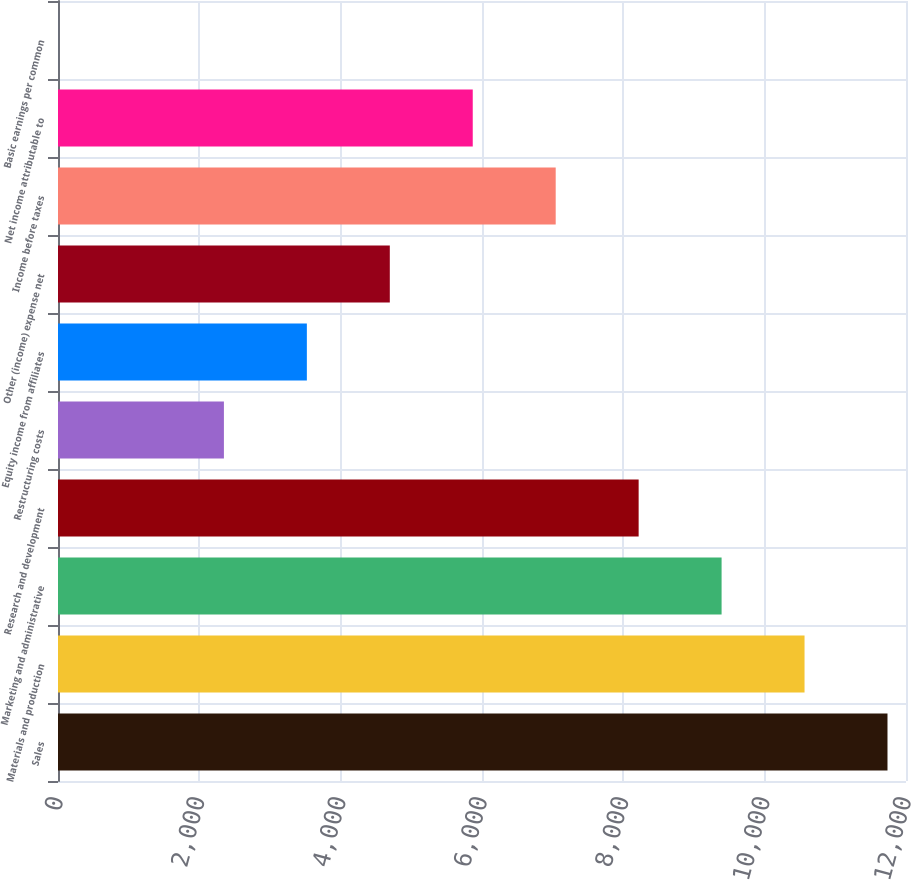Convert chart to OTSL. <chart><loc_0><loc_0><loc_500><loc_500><bar_chart><fcel>Sales<fcel>Materials and production<fcel>Marketing and administrative<fcel>Research and development<fcel>Restructuring costs<fcel>Equity income from affiliates<fcel>Other (income) expense net<fcel>Income before taxes<fcel>Net income attributable to<fcel>Basic earnings per common<nl><fcel>11738<fcel>10564.2<fcel>9390.46<fcel>8216.69<fcel>2347.84<fcel>3521.61<fcel>4695.38<fcel>7042.92<fcel>5869.15<fcel>0.3<nl></chart> 